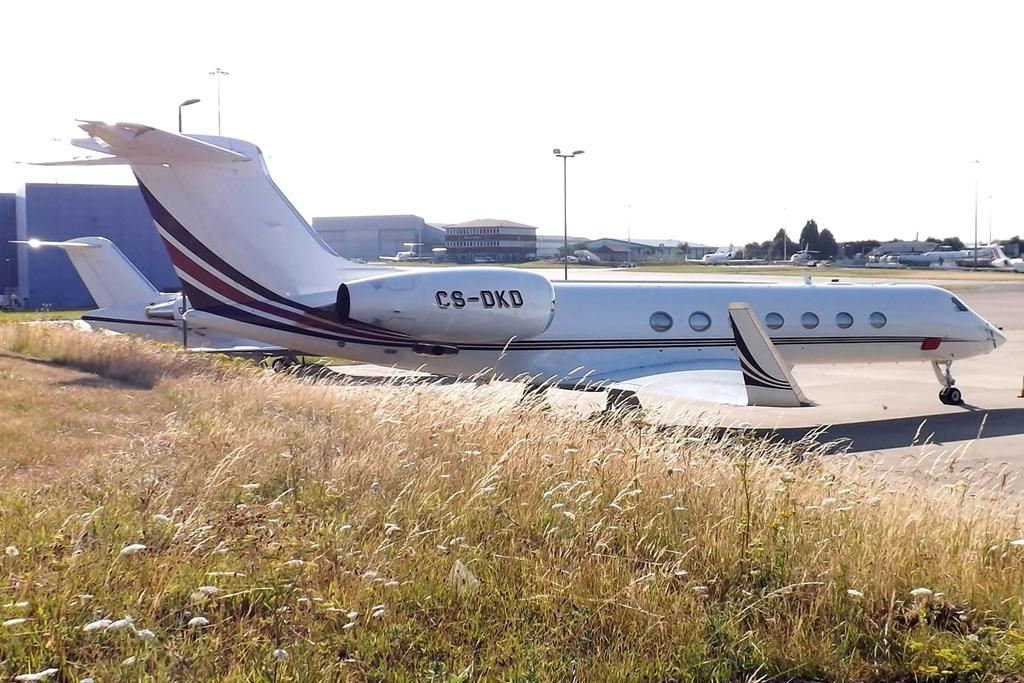<image>
Provide a brief description of the given image. the letters CS are on the back of a plane 